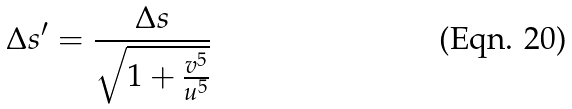<formula> <loc_0><loc_0><loc_500><loc_500>\Delta s ^ { \prime } = \frac { \Delta s } { \sqrt { 1 + \frac { v ^ { 5 } } { u ^ { 5 } } } }</formula> 